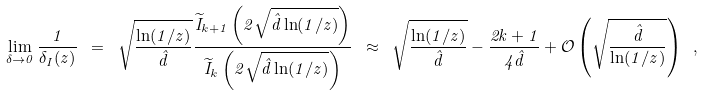Convert formula to latex. <formula><loc_0><loc_0><loc_500><loc_500>\lim _ { \delta \to 0 } \frac { 1 } { \delta _ { I } ( z ) } \ = \ \sqrt { \frac { \ln ( 1 / z ) } { \hat { d } } } \frac { \widetilde { I } _ { k + 1 } \left ( 2 \sqrt { \hat { d } \ln ( 1 / z ) } \right ) } { \widetilde { I } _ { k } \left ( 2 \sqrt { \hat { d } \ln ( 1 / z ) } \right ) } \ \approx \ \sqrt { \frac { \ln ( 1 / z ) } { \hat { d } } } - \frac { 2 k + 1 } { 4 \hat { d } } + \mathcal { O } \left ( \sqrt { \frac { \hat { d } } { \ln ( 1 / z ) } } \right ) \ ,</formula> 